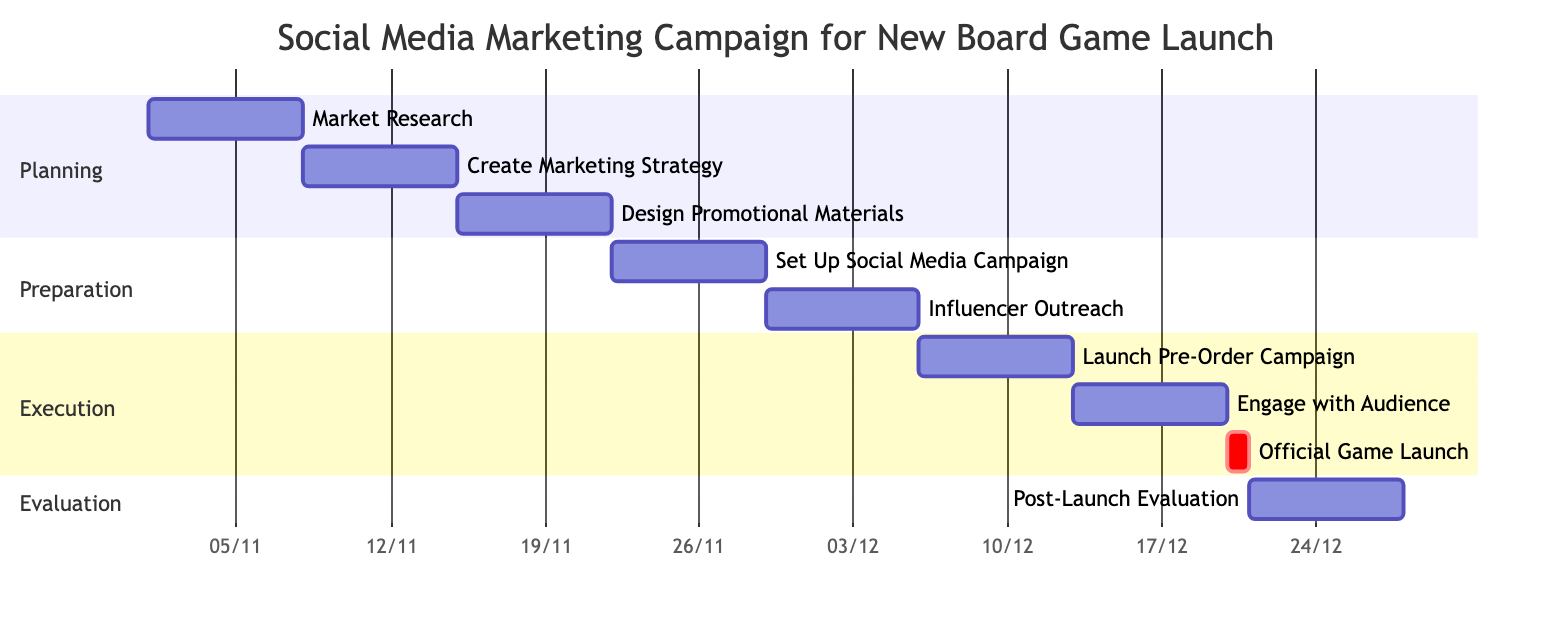What is the duration of the "Market Research" task? The "Market Research" task spans from November 1 to November 7, which is a total of 7 days.
Answer: 7 days What task follows "Design Promotional Materials"? The task that follows "Design Promotional Materials" is "Set Up Social Media Campaign," which starts on November 22 immediately after the previous task ends on November 21.
Answer: Set Up Social Media Campaign How many sections are there in the Gantt chart? The Gantt chart has four sections: Planning, Preparation, Execution, and Evaluation.
Answer: 4 What is the end date of the "Engage with Audience" task? The "Engage with Audience" task ends on December 19; this can be found directly next to the task's entry.
Answer: December 19 Which task is classified as a critical task in the execution section? The "Official Game Launch" is marked as a critical task, as indicated by the "crit" label next to it.
Answer: Official Game Launch What task is scheduled directly before the "Post-Launch Evaluation"? The task scheduled directly before "Post-Launch Evaluation" is "Official Game Launch," which takes place on December 20.
Answer: Official Game Launch How many days are allocated for the "Influencer Outreach"? "Influencer Outreach" is allocated 7 days, starting from November 29 and ending on December 5.
Answer: 7 days What is the earliest start date of any task in the campaign? The earliest start date of any task in the campaign is November 1, which is when the "Market Research" begins.
Answer: November 1 What is the total number of tasks in the Gantt chart? The Gantt chart lists a total of 9 tasks, spanning the entire campaign from start to finish.
Answer: 9 